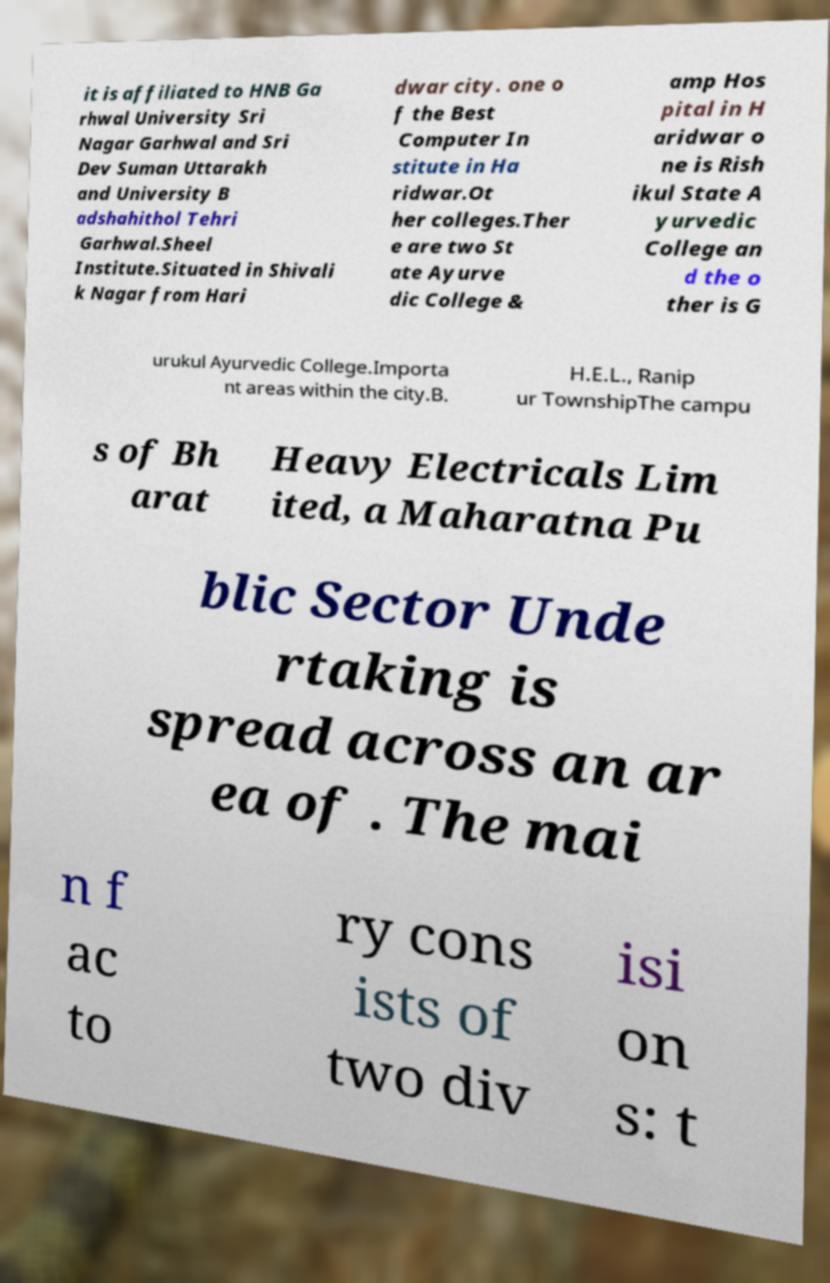I need the written content from this picture converted into text. Can you do that? it is affiliated to HNB Ga rhwal University Sri Nagar Garhwal and Sri Dev Suman Uttarakh and University B adshahithol Tehri Garhwal.Sheel Institute.Situated in Shivali k Nagar from Hari dwar city. one o f the Best Computer In stitute in Ha ridwar.Ot her colleges.Ther e are two St ate Ayurve dic College & amp Hos pital in H aridwar o ne is Rish ikul State A yurvedic College an d the o ther is G urukul Ayurvedic College.Importa nt areas within the city.B. H.E.L., Ranip ur TownshipThe campu s of Bh arat Heavy Electricals Lim ited, a Maharatna Pu blic Sector Unde rtaking is spread across an ar ea of . The mai n f ac to ry cons ists of two div isi on s: t 